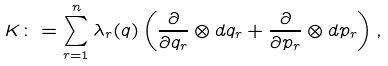Convert formula to latex. <formula><loc_0><loc_0><loc_500><loc_500>K \colon = \sum _ { r = 1 } ^ { n } \lambda _ { r } ( q ) \left ( \frac { \partial } { \partial q _ { r } } \otimes d q _ { r } + \frac { \partial } { \partial p _ { r } } \otimes d p _ { r } \right ) ,</formula> 